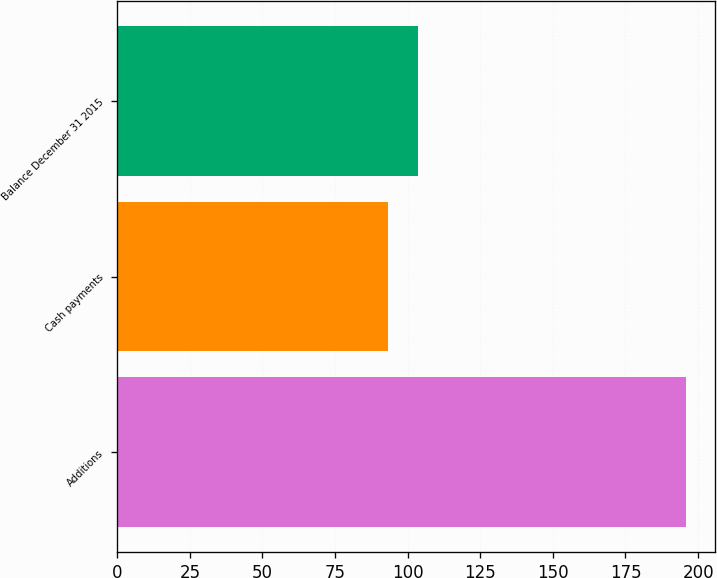<chart> <loc_0><loc_0><loc_500><loc_500><bar_chart><fcel>Additions<fcel>Cash payments<fcel>Balance December 31 2015<nl><fcel>196<fcel>93.1<fcel>103.39<nl></chart> 